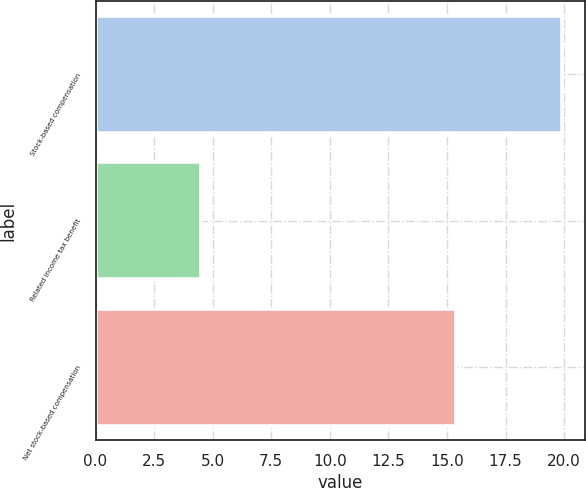<chart> <loc_0><loc_0><loc_500><loc_500><bar_chart><fcel>Stock-based compensation<fcel>Related income tax benefit<fcel>Net stock-based compensation<nl><fcel>19.9<fcel>4.5<fcel>15.4<nl></chart> 